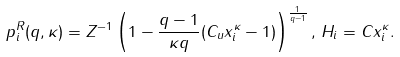<formula> <loc_0><loc_0><loc_500><loc_500>p ^ { R } _ { i } ( q , \kappa ) = Z ^ { - 1 } \left ( 1 - \frac { q - 1 } { \kappa q } ( C _ { u } x ^ { \kappa } _ { i } - 1 ) \right ) ^ { \frac { 1 } { q - 1 } } , \, H _ { i } = C x _ { i } ^ { \kappa } .</formula> 